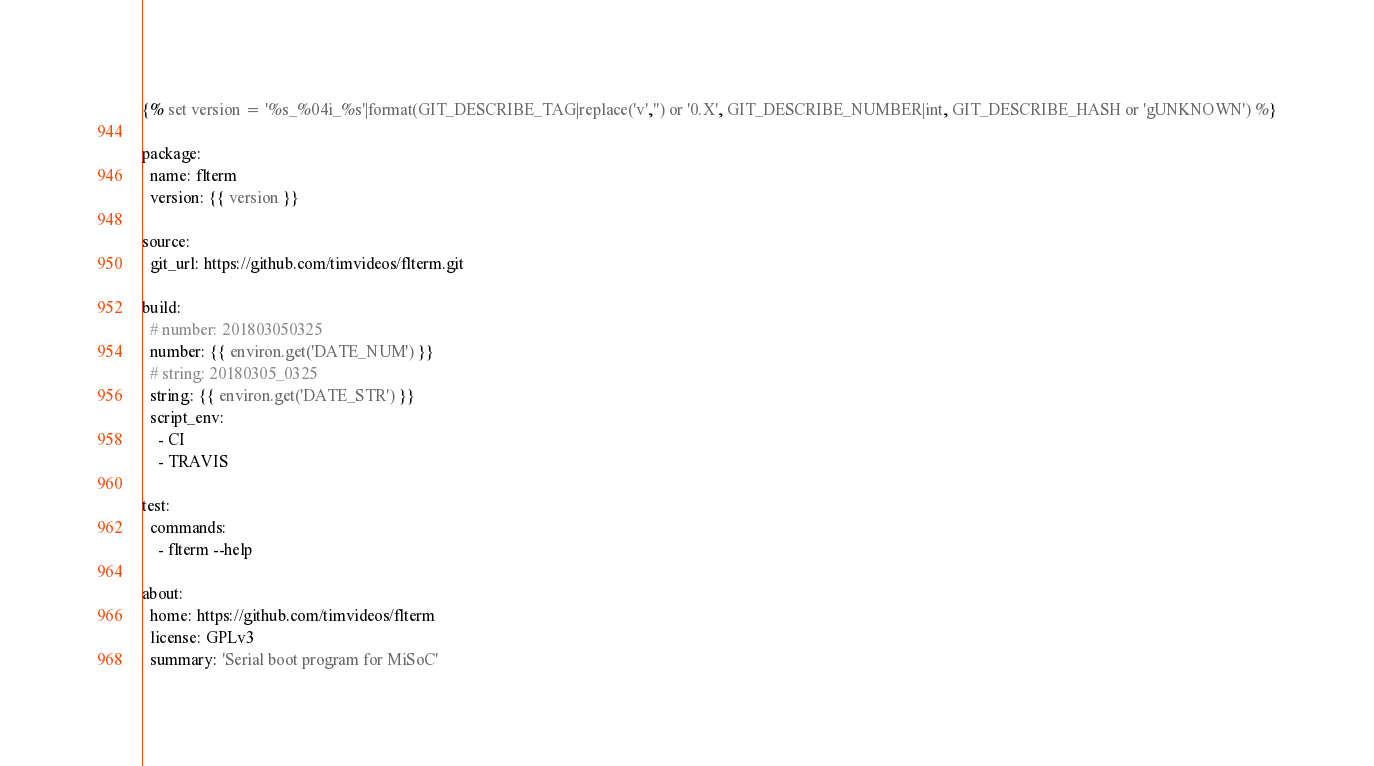<code> <loc_0><loc_0><loc_500><loc_500><_YAML_>{% set version = '%s_%04i_%s'|format(GIT_DESCRIBE_TAG|replace('v','') or '0.X', GIT_DESCRIBE_NUMBER|int, GIT_DESCRIBE_HASH or 'gUNKNOWN') %}

package:
  name: flterm
  version: {{ version }}

source:
  git_url: https://github.com/timvideos/flterm.git

build:
  # number: 201803050325
  number: {{ environ.get('DATE_NUM') }}
  # string: 20180305_0325
  string: {{ environ.get('DATE_STR') }}
  script_env:
    - CI
    - TRAVIS

test:
  commands:
    - flterm --help

about:
  home: https://github.com/timvideos/flterm
  license: GPLv3
  summary: 'Serial boot program for MiSoC'
</code> 